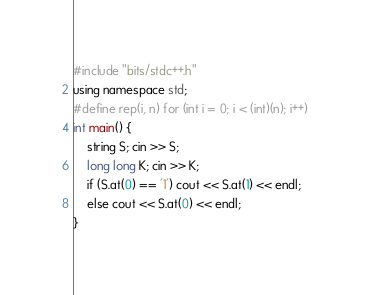Convert code to text. <code><loc_0><loc_0><loc_500><loc_500><_C++_>#include "bits/stdc++.h"
using namespace std;
#define rep(i, n) for (int i = 0; i < (int)(n); i++)
int main() {
	string S; cin >> S;
	long long K; cin >> K;
	if (S.at(0) == '1') cout << S.at(1) << endl;
	else cout << S.at(0) << endl;
}
</code> 